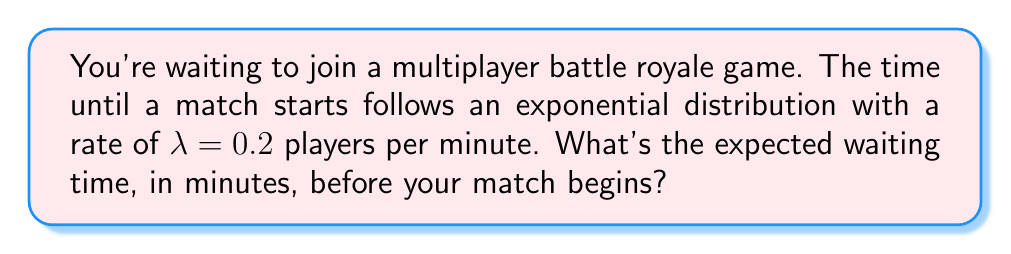Can you solve this math problem? Let's approach this step-by-step:

1) For an exponential distribution, the expected value (mean) is given by:

   $$E[X] = \frac{1}{\lambda}$$

   Where $\lambda$ is the rate parameter.

2) We're given that $\lambda = 0.2$ players per minute.

3) Substituting this into our formula:

   $$E[X] = \frac{1}{0.2}$$

4) Simplifying:

   $$E[X] = 5$$

5) Therefore, the expected waiting time is 5 minutes.

This means that, on average, you'll wait 5 minutes before a match starts. Sometimes you'll wait less, sometimes more, but over many games, it'll average out to 5 minutes.
Answer: 5 minutes 